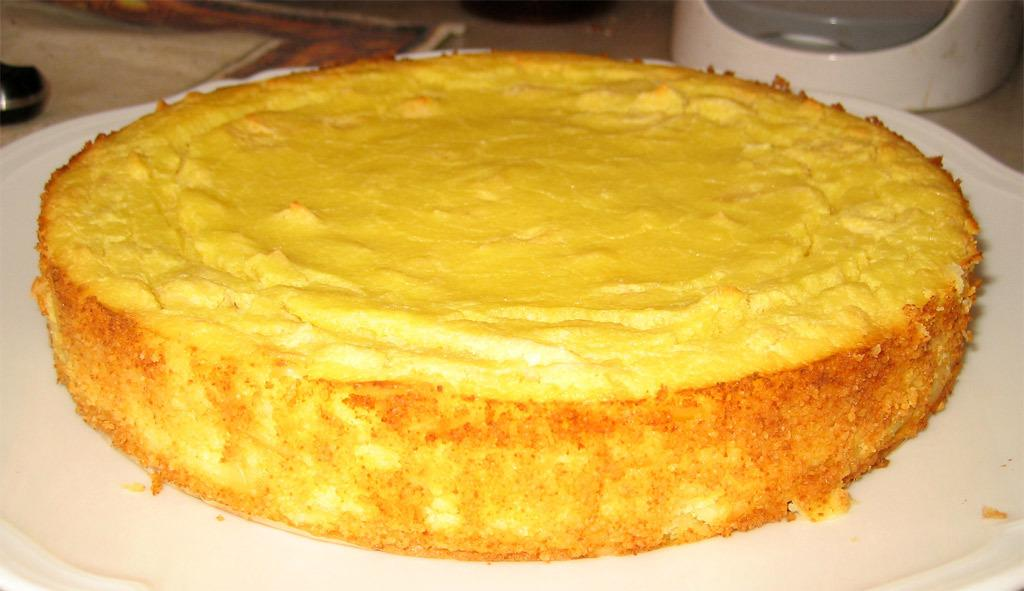What is the main subject of the image? The main subject of the image is a cake. How is the cake positioned in the image? The cake is on a plate. What type of sugar is used to decorate the cake in the image? There is no information about the type of sugar used to decorate the cake in the image. What thoughts are going through the cake's mind in the image? Cakes do not have minds or thoughts, so this question cannot be answered. 